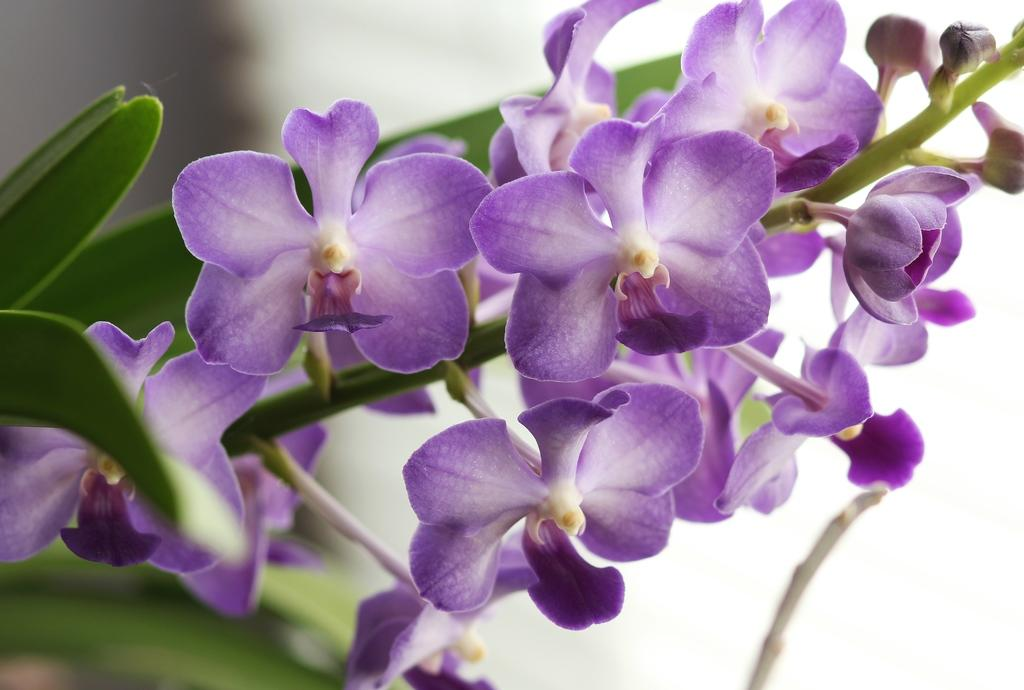What type of plant elements are present in the image? The image contains flowers, leaves, and stems. Can you describe the background of the image? The background of the image is blurred. How many babies are visible in the image? There are no babies present in the image; it features flowers, leaves, and stems. What type of plants can be seen interacting with the squirrel in the image? There is no squirrel present in the image, and therefore no interaction with plants can be observed. 